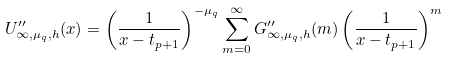Convert formula to latex. <formula><loc_0><loc_0><loc_500><loc_500>U ^ { \prime \prime } _ { \infty , \mu _ { q } , h } ( x ) = \left ( \frac { 1 } { x - t _ { p + 1 } } \right ) ^ { - \mu _ { q } } \sum _ { m = 0 } ^ { \infty } G ^ { \prime \prime } _ { \infty , \mu _ { q } , h } ( m ) \left ( \frac { 1 } { x - t _ { p + 1 } } \right ) ^ { m }</formula> 